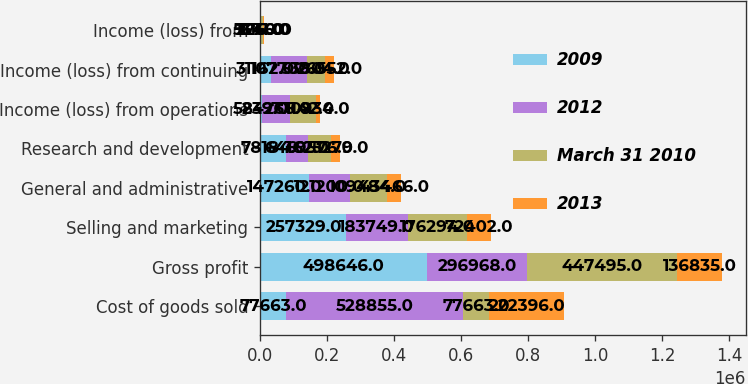<chart> <loc_0><loc_0><loc_500><loc_500><stacked_bar_chart><ecel><fcel>Cost of goods sold<fcel>Gross profit<fcel>Selling and marketing<fcel>General and administrative<fcel>Research and development<fcel>Income (loss) from operations<fcel>Income (loss) from continuing<fcel>Income (loss) from<nl><fcel>2009<fcel>77663<fcel>498646<fcel>257329<fcel>147260<fcel>78184<fcel>5239<fcel>31162<fcel>1671<nl><fcel>2012<fcel>528855<fcel>296968<fcel>183749<fcel>121200<fcel>64162<fcel>84266<fcel>107700<fcel>1116<nl><fcel>March 31 2010<fcel>77663<fcel>447495<fcel>176294<fcel>109484<fcel>69576<fcel>77142<fcel>53804<fcel>5346<nl><fcel>2013<fcel>222396<fcel>136835<fcel>72402<fcel>43466<fcel>25279<fcel>10934<fcel>26552<fcel>2250<nl></chart> 